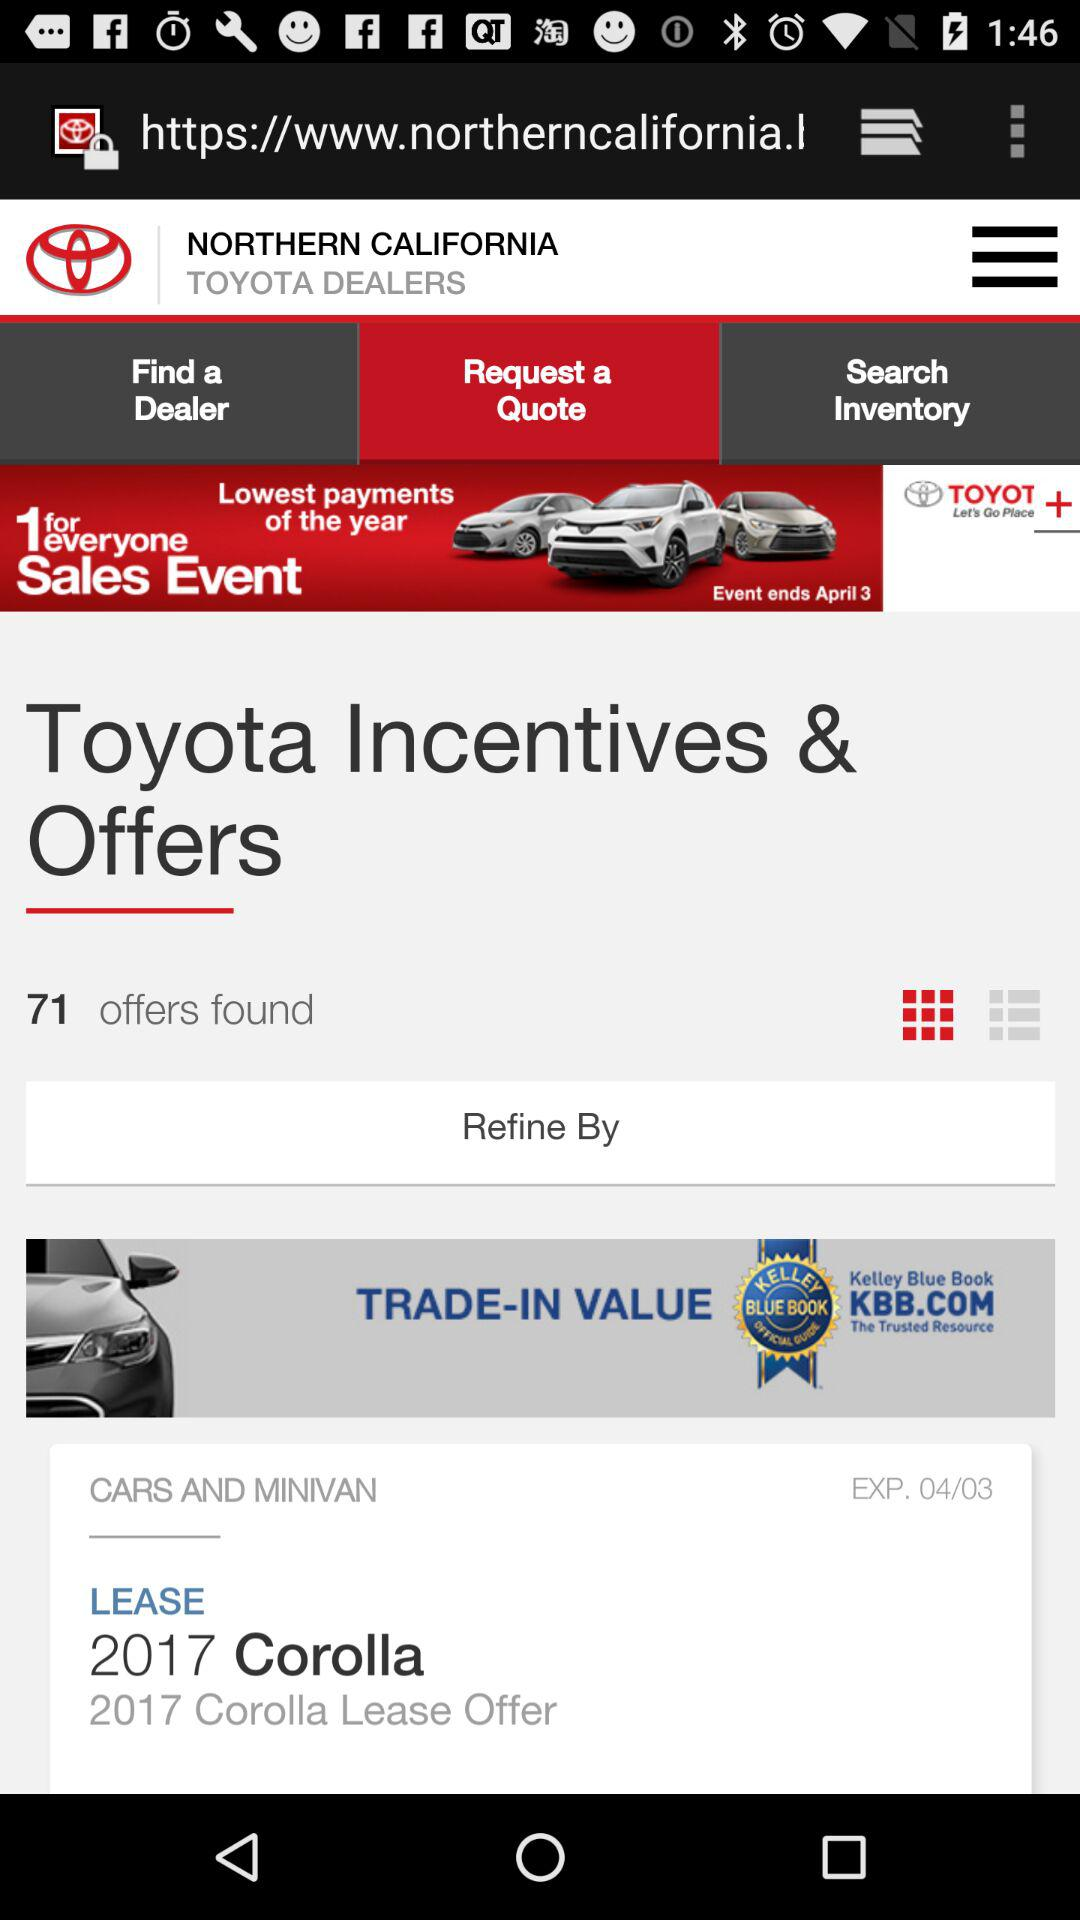What is the expiration date? The expiration date is April 3. 